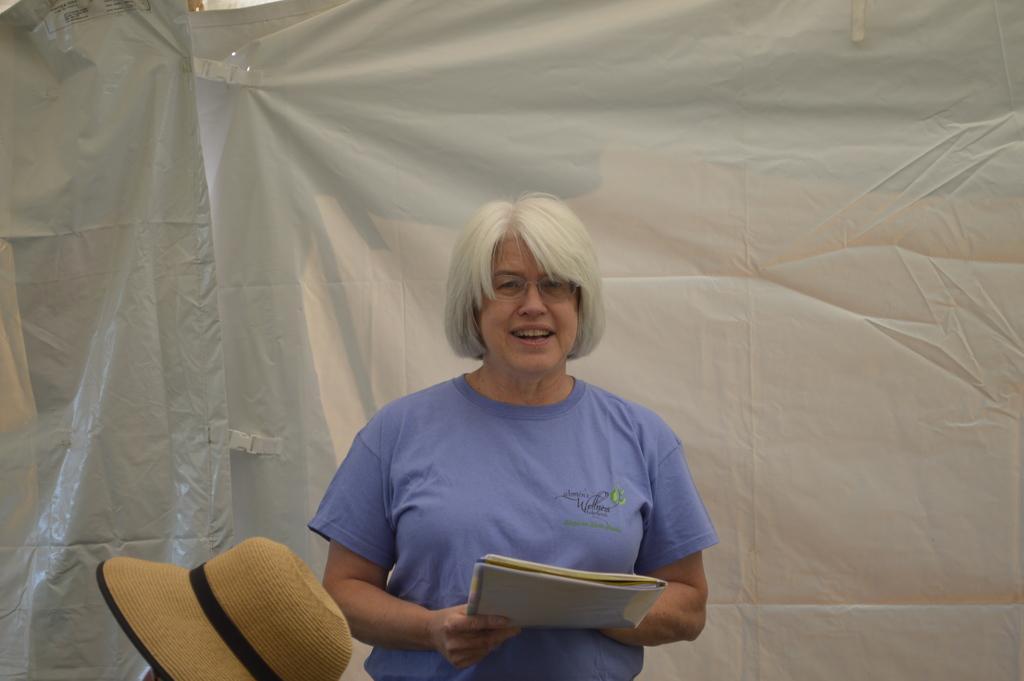Please provide a concise description of this image. In this image I can see a person standing and holding a book. There is a hat and in the background there are tarpaulin covers or sheets. 